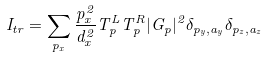Convert formula to latex. <formula><loc_0><loc_0><loc_500><loc_500>I _ { t r } = \sum _ { p _ { x } } \frac { p _ { x } ^ { 2 } } { d _ { x } ^ { 2 } } T ^ { L } _ { p } T ^ { R } _ { p } | G _ { p } | ^ { 2 } \delta _ { { p } _ { y } , { a } _ { y } } \delta _ { { p } _ { z } , { a } _ { z } }</formula> 